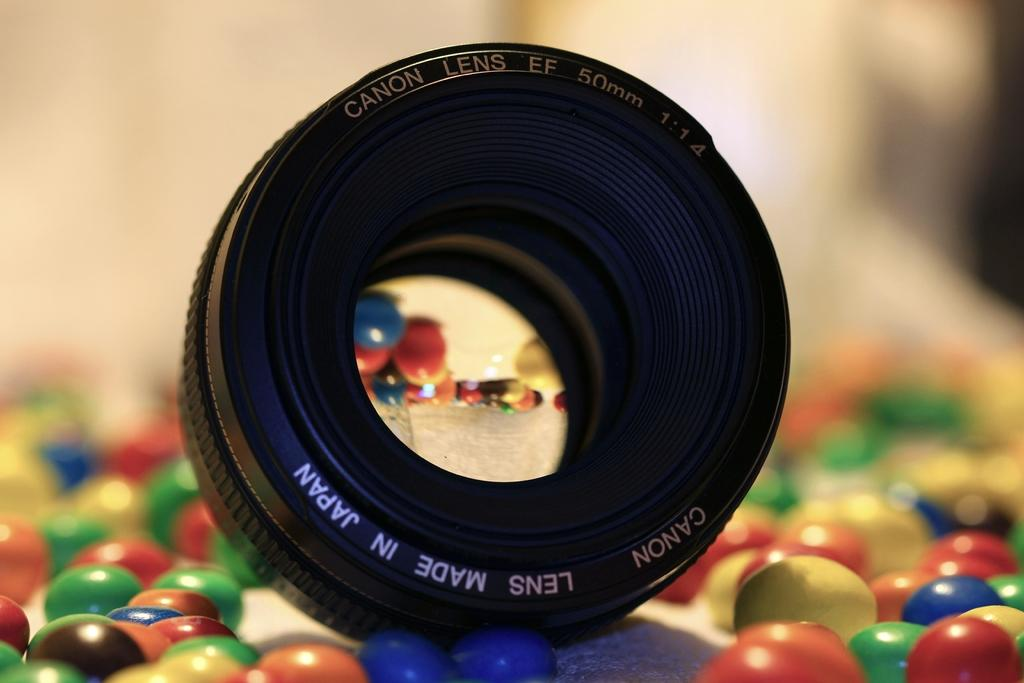What is the main subject of the image? The main subject of the image is a camera lens. Are there any other items visible in the image besides the camera lens? Yes, there are chocolate gems in the image. What type of underwear is the spy wearing in the image? There is no spy or underwear present in the image; it only features a camera lens and chocolate gems. 